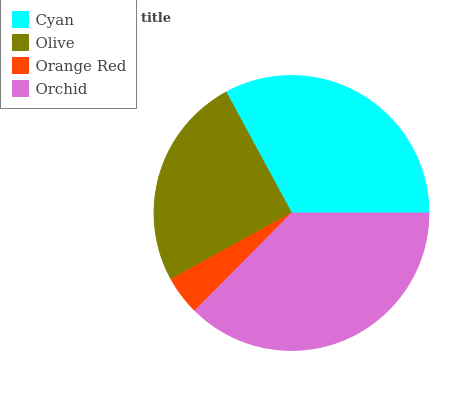Is Orange Red the minimum?
Answer yes or no. Yes. Is Orchid the maximum?
Answer yes or no. Yes. Is Olive the minimum?
Answer yes or no. No. Is Olive the maximum?
Answer yes or no. No. Is Cyan greater than Olive?
Answer yes or no. Yes. Is Olive less than Cyan?
Answer yes or no. Yes. Is Olive greater than Cyan?
Answer yes or no. No. Is Cyan less than Olive?
Answer yes or no. No. Is Cyan the high median?
Answer yes or no. Yes. Is Olive the low median?
Answer yes or no. Yes. Is Orange Red the high median?
Answer yes or no. No. Is Orange Red the low median?
Answer yes or no. No. 